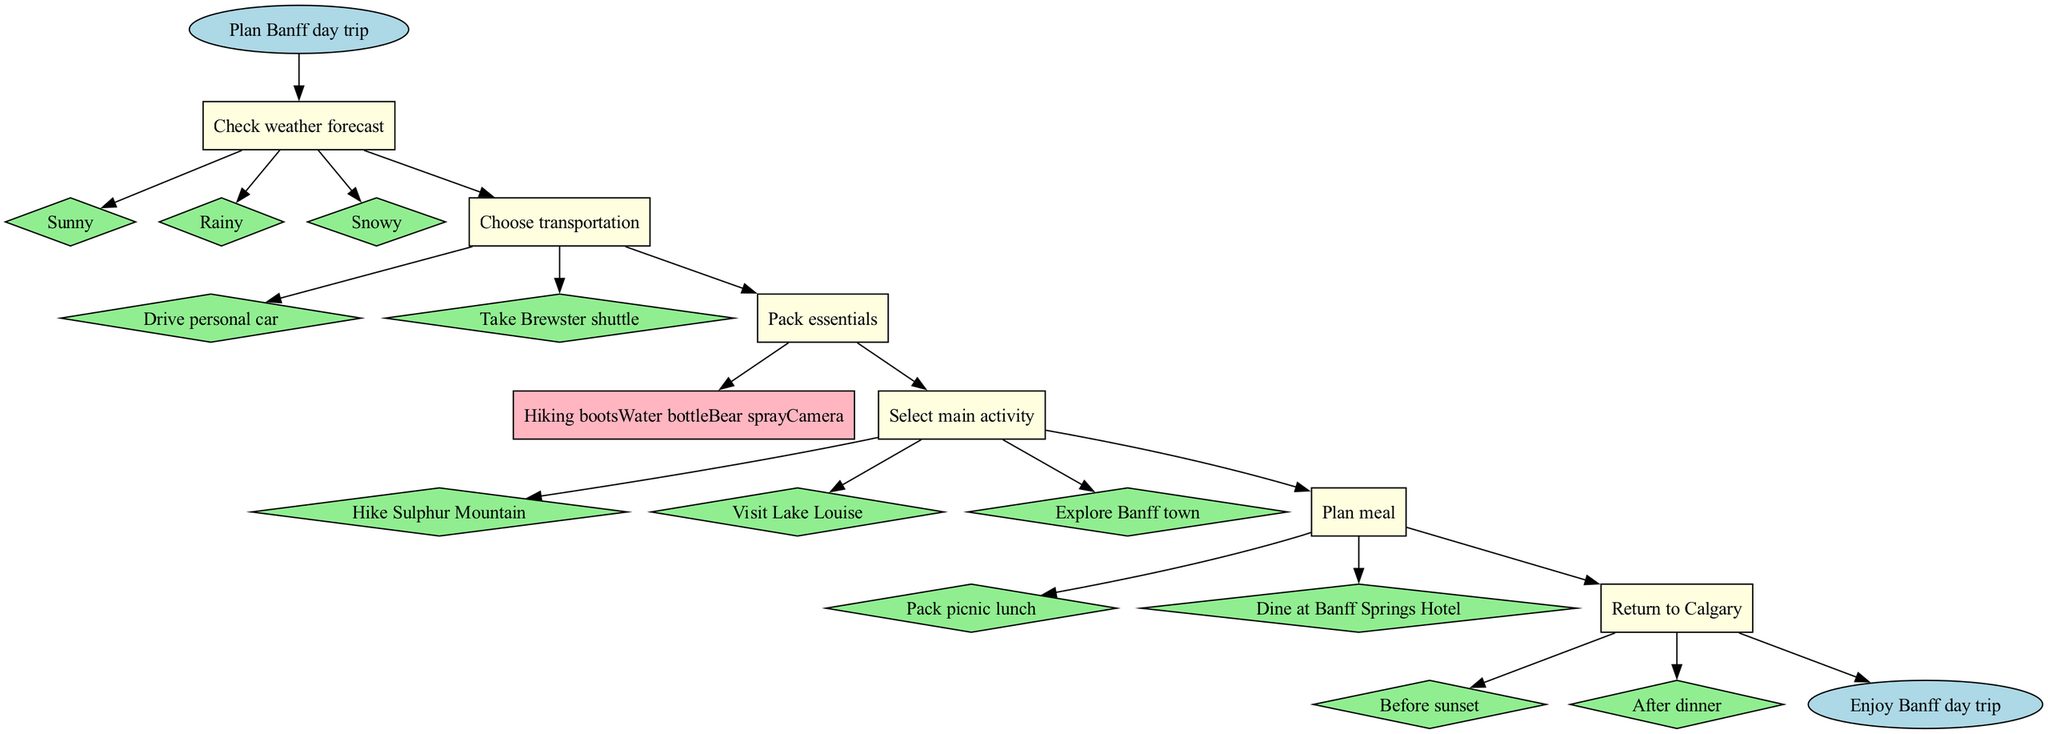What is the first step in planning the trip? The first step listed in the diagram is "Check weather forecast." This is indicated as the first node connected to the "Plan Banff day trip" start node.
Answer: Check weather forecast How many main activities are options for the trip? The diagram shows three options under the "Select main activity" step: "Hike Sulphur Mountain," "Visit Lake Louise," and "Explore Banff town." Thus, there are three options total.
Answer: 3 What needs to be packed for the trip? Under the "Pack essentials" step, the items listed are "Hiking boots," "Water bottle," "Bear spray," and "Camera." The answer includes all of these essentials as they are directly shown in the diagram.
Answer: Hiking boots, Water bottle, Bear spray, Camera If the weather is rainy, what would be the next step to follow? Following the "Check weather forecast" step, if the weather is rainy, the next step is "Choose transportation." This relationship is indicated by the flow from weather options to transportation choices in the diagram.
Answer: Choose transportation What meal planning options are provided? The diagram shows two options under the "Plan meal" step: "Pack picnic lunch" and "Dine at Banff Springs Hotel." The answer includes both options as displayed in the diagram.
Answer: Pack picnic lunch, Dine at Banff Springs Hotel Which step comes before "Return to Calgary"? The step immediately preceding "Return to Calgary" in the flow is "Plan meal." This is determined by following the direction of edges in the diagram, which shows the order of steps.
Answer: Plan meal What is the last activity shown in the diagram? The last activity listed before the "Enjoy Banff day trip" end node is "Return to Calgary." This can be found by following the flow from the last decision point back to the terminal node of the diagram.
Answer: Return to Calgary What are the options for transportation? The options for transportation listed in the "Choose transportation" step are "Drive personal car" and "Take Brewster shuttle." The options are connected to this specific step in the flow chart.
Answer: Drive personal car, Take Brewster shuttle If the main activity selected is "Visit Lake Louise," what is the next step? Regardless of the main activity chosen, the flow from "Select main activity" leads directly to "Plan meal," which follows it in the diagram. Therefore, the next step after choosing "Visit Lake Louise" is still "Plan meal."
Answer: Plan meal 